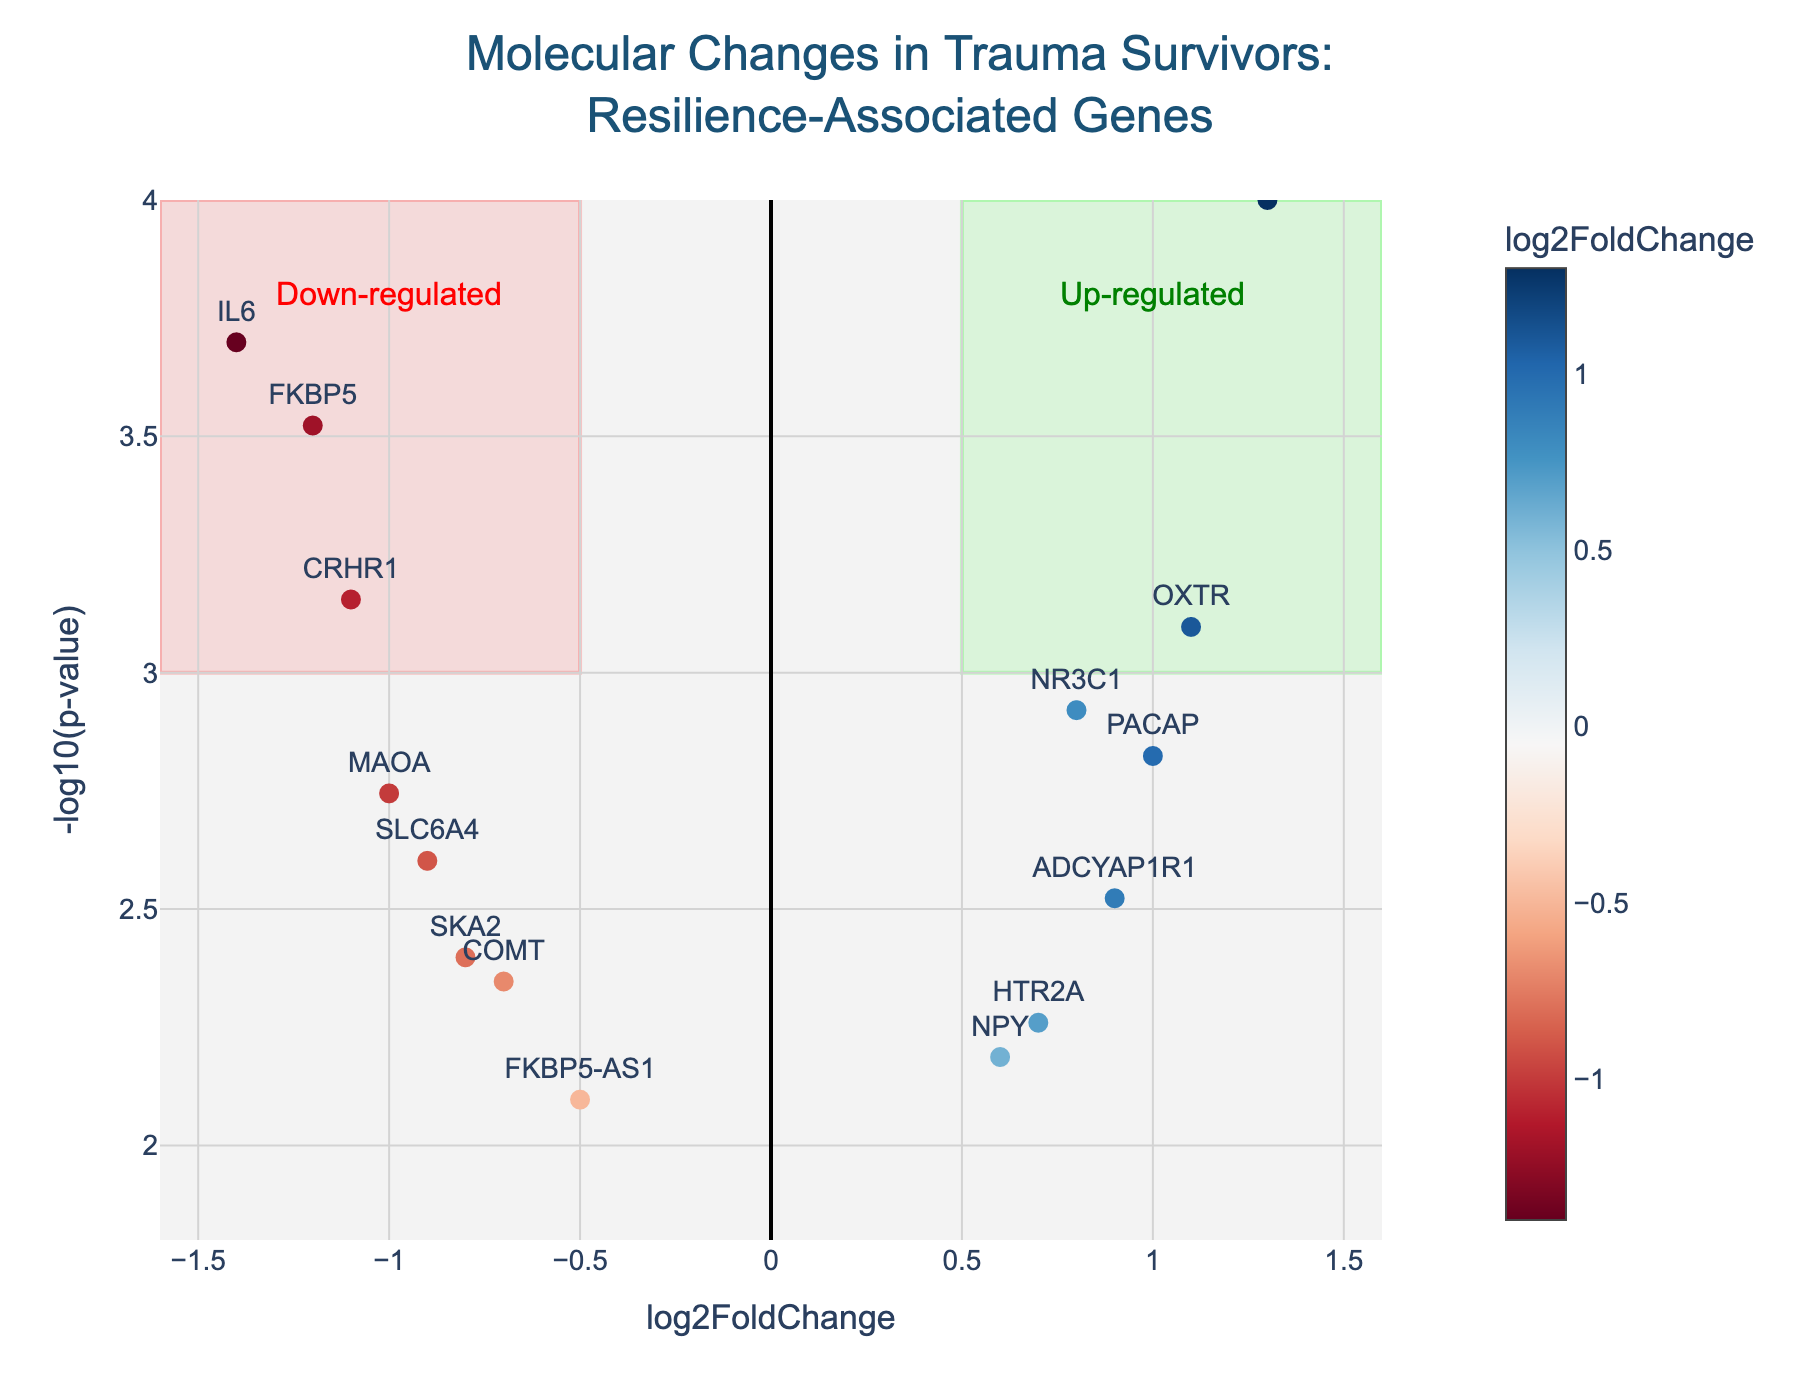What is the title of the plot? The title is located at the top of the plot and it reads "Molecular Changes in Trauma Survivors: Resilience-Associated Genes".
Answer: Molecular Changes in Trauma Survivors: Resilience-Associated Genes How many genes are up-regulated with a -log10(p-value) greater than 3? Up-regulated genes are those with a positive log2FoldChange, and we look for points to the right of 0 on the x-axis and above 3 on the y-axis. The specific genes are OXTR, BDNF, and PACAP.
Answer: 3 Which gene has the highest -log10(p-value)? The gene with the highest -log10(p-value) will be the one located highest on the y-axis. BDNF appears to be the highest.
Answer: BDNF How does FKBP5 compare to NR3C1 in terms of log2FoldChange and -log10(p-value)? FKBP5 has a log2FoldChange of -1.2 and a -log10(p-value) around 3.52. NR3C1 has a log2FoldChange of 0.8 and a -log10(p-value) around 2.92. Thus, FKBP5 is down-regulated more strongly with a more significant p-value, while NR3C1 is up-regulated.
Answer: FKBP5 is down-regulated with a more significant p-value; NR3C1 is up-regulated Which genes are in the "down-regulated" zone marked in light red? The "down-regulated" zone is between -1.6 and -0.5 on the x-axis and above 3 on the y-axis. The genes in this range are IL6, FKBP5, and CRHR1.
Answer: IL6, FKBP5, CRHR1 What is the range of log2FoldChange covered by the plot? The x-axis range is specified from -1.6 to 1.6 by the plot settings. This indicates the full range of log2FoldChange represented.
Answer: -1.6 to 1.6 Which gene has the most significant p-value (lowest -log10(p-value)) and how is it regulated? The gene with the lowest -log10(p-value) is FKBP5-AS1, as indicated by its position on the y-axis. It is down-regulated since its log2FoldChange is -0.5.
Answer: FKBP5-AS1, down-regulated What information do the colors of the points convey in the plot? The colors represent the log2FoldChange, with a color scale from blue (down-regulated) to red (up-regulated), as indicated by the color bar on the right side of the plot.
Answer: Log2FoldChange How many genes have a p-value less than 0.001? We need to count the points above -log10(p-value) of 3 on the y-axis. The genes are FKBP5, OXTR, BDNF, CRHR1, IL6.
Answer: 5 